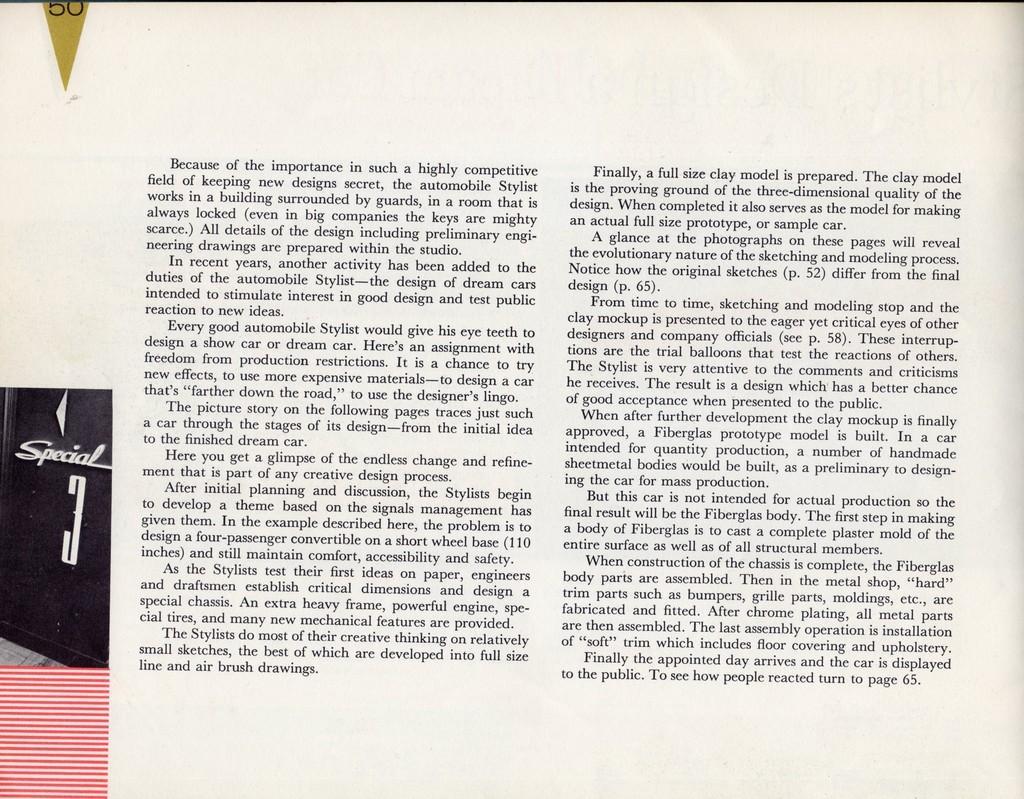Describe this image in one or two sentences. In this image, we can see a photo of a paper, we can see some text on the paper. 